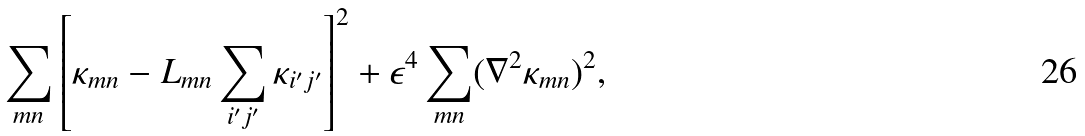<formula> <loc_0><loc_0><loc_500><loc_500>\sum _ { m n } \left [ \kappa _ { m n } - L _ { m n } \sum _ { i ^ { \prime } j ^ { \prime } } \kappa _ { i ^ { \prime } j ^ { \prime } } \right ] ^ { 2 } + \epsilon ^ { 4 } \sum _ { m n } ( \nabla ^ { 2 } \kappa _ { m n } ) ^ { 2 } ,</formula> 